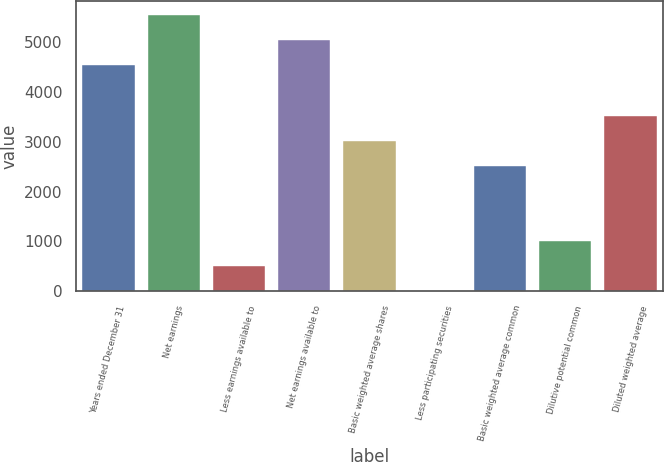Convert chart to OTSL. <chart><loc_0><loc_0><loc_500><loc_500><bar_chart><fcel>Years ended December 31<fcel>Net earnings<fcel>Less earnings available to<fcel>Net earnings available to<fcel>Basic weighted average shares<fcel>Less participating securities<fcel>Basic weighted average common<fcel>Dilutive potential common<fcel>Diluted weighted average<nl><fcel>4530.7<fcel>5537.3<fcel>504.3<fcel>5034<fcel>3020.8<fcel>1<fcel>2517.5<fcel>1007.6<fcel>3524.1<nl></chart> 